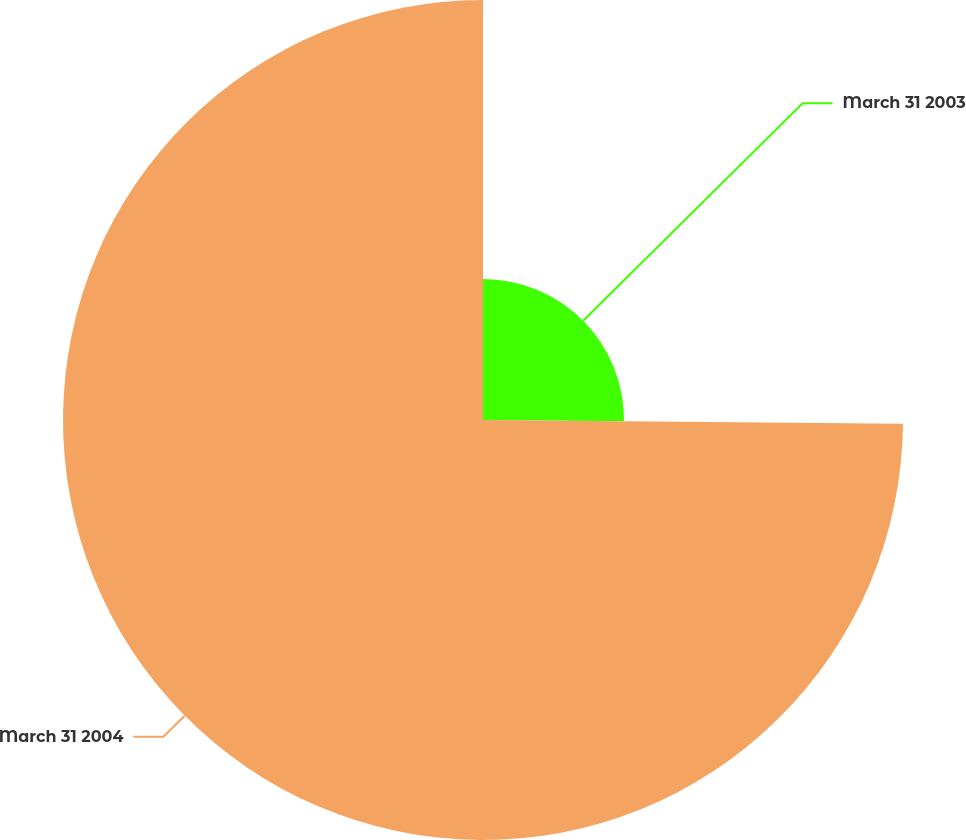<chart> <loc_0><loc_0><loc_500><loc_500><pie_chart><fcel>March 31 2003<fcel>March 31 2004<nl><fcel>25.14%<fcel>74.86%<nl></chart> 